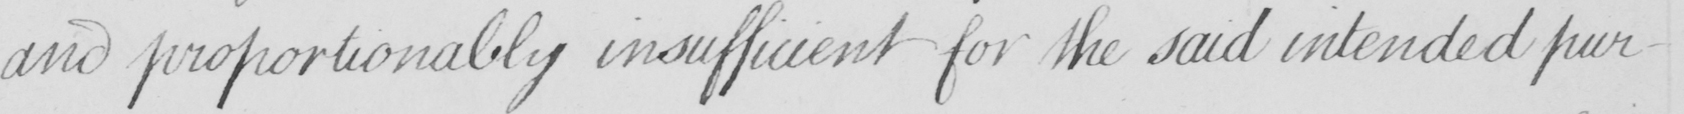Can you tell me what this handwritten text says? and proportionably insufficient for the said intended pur- 